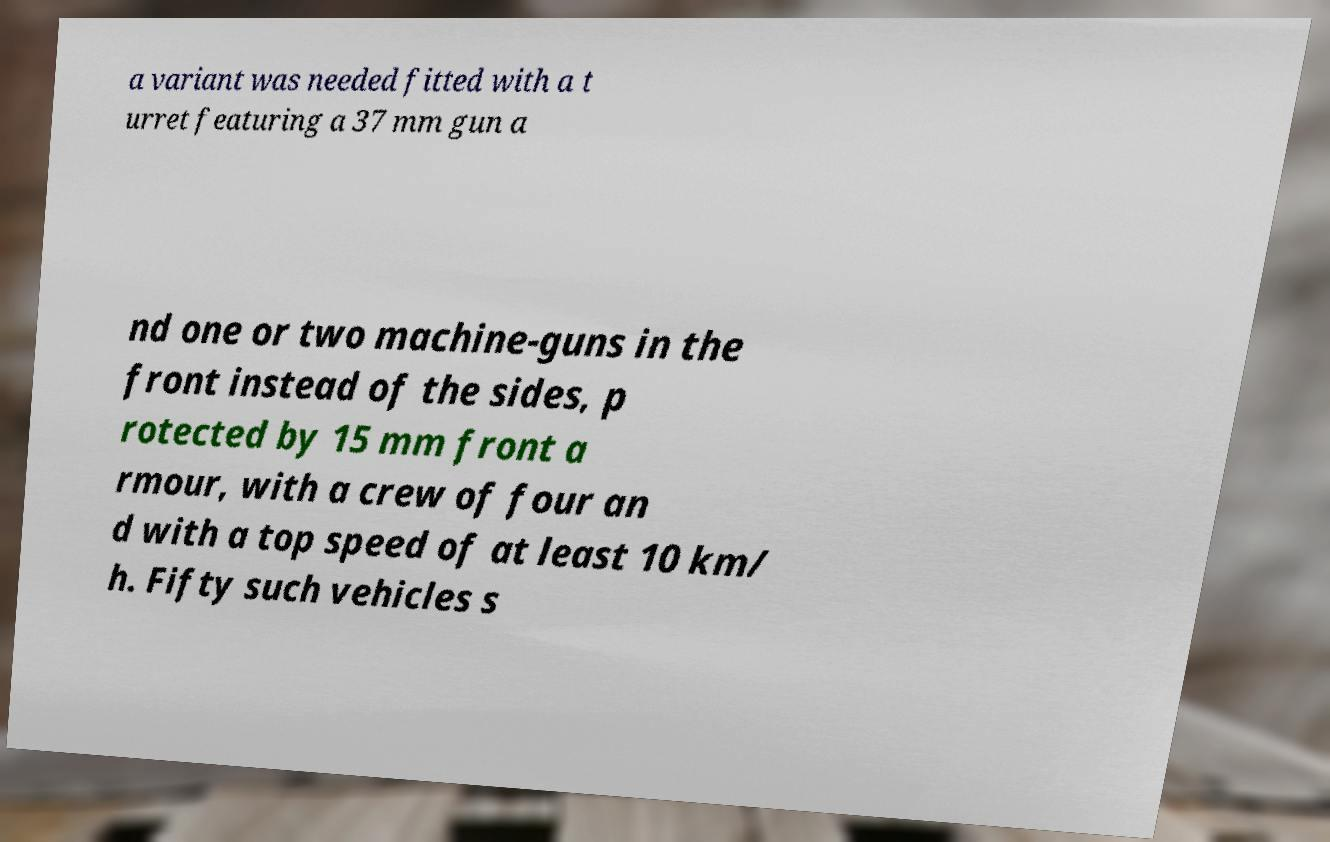There's text embedded in this image that I need extracted. Can you transcribe it verbatim? a variant was needed fitted with a t urret featuring a 37 mm gun a nd one or two machine-guns in the front instead of the sides, p rotected by 15 mm front a rmour, with a crew of four an d with a top speed of at least 10 km/ h. Fifty such vehicles s 